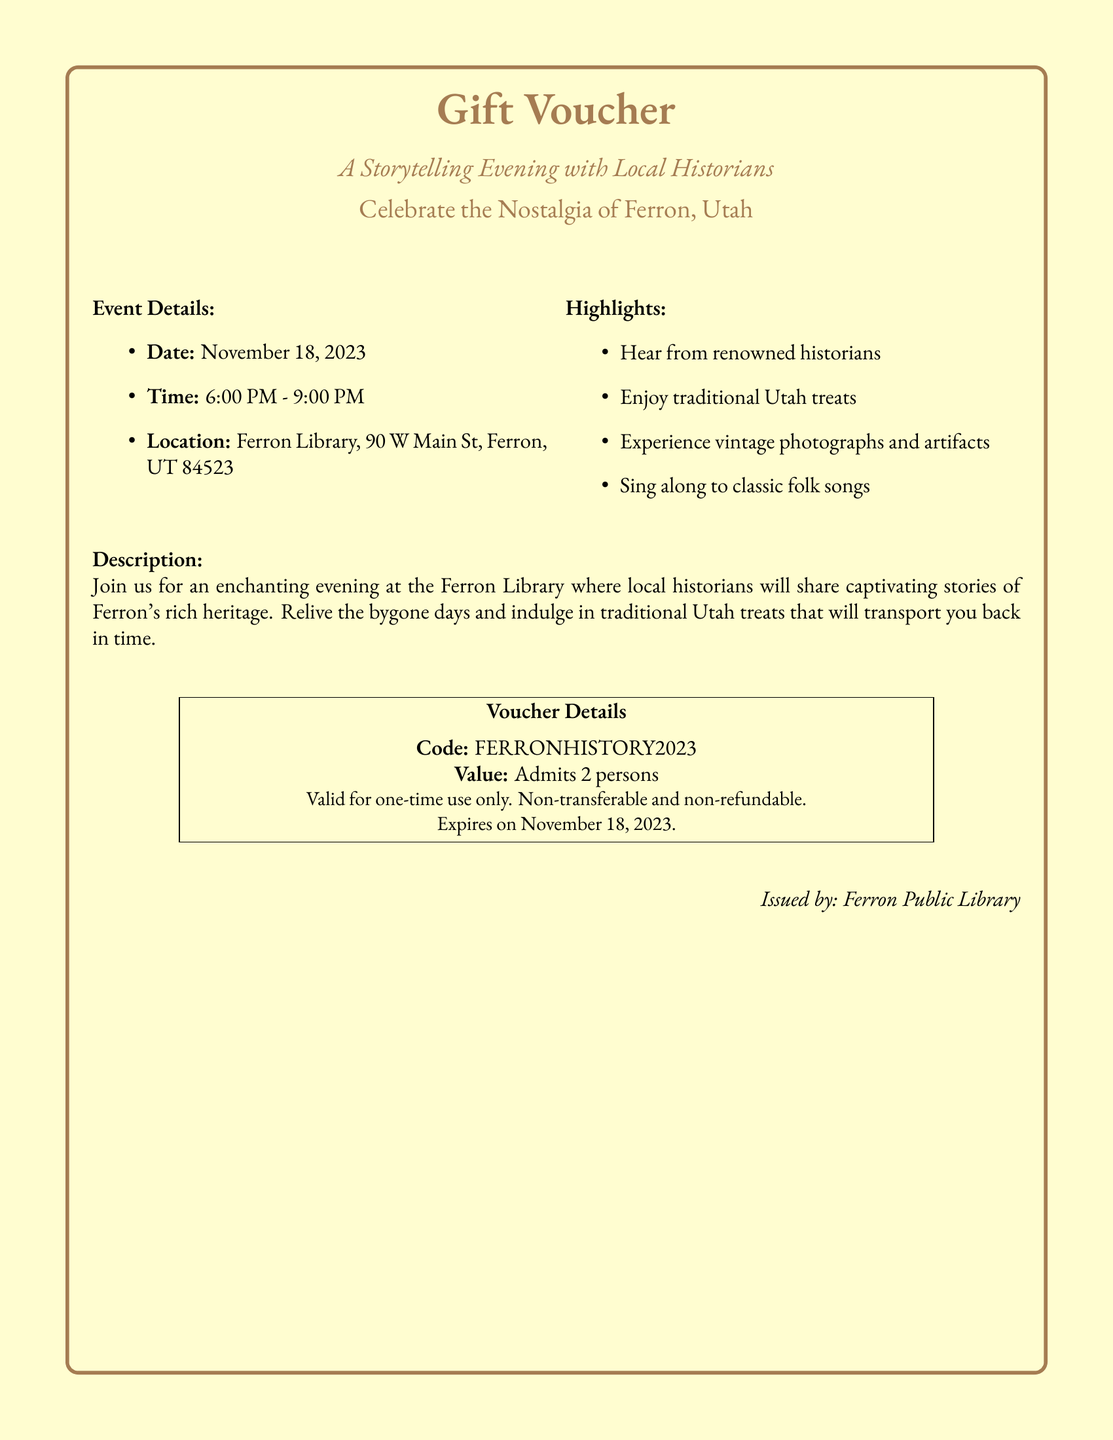What is the date of the event? The event date is explicitly mentioned in the document as November 18, 2023.
Answer: November 18, 2023 What time does the event start? The event's start time is provided in the details, which states it begins at 6:00 PM.
Answer: 6:00 PM Where is the event taking place? The location of the event is clearly defined in the document as Ferron Library, 90 W Main St, Ferron, UT 84523.
Answer: Ferron Library, 90 W Main St, Ferron, UT 84523 How many people does the voucher admit? The voucher details specify that it admits 2 persons, making this information clear and straightforward.
Answer: 2 persons What is the code on the voucher? The document lists the specific voucher code FERRONHISTORY2023.
Answer: FERRONHISTORY2023 What are attendees encouraged to enjoy during the event? The highlights section indicates that attendees can enjoy traditional Utah treats along with captivating stories.
Answer: Traditional Utah treats What is the expiration date of the voucher? The document mentions that the voucher expires on November 18, 2023, which indicates its validity window.
Answer: November 18, 2023 What type of event is this voucher for? The title and description of the event clearly state that it is a storytelling evening with local historians.
Answer: A storytelling evening Who issued the voucher? The document mentions that the voucher is issued by Ferron Public Library.
Answer: Ferron Public Library 